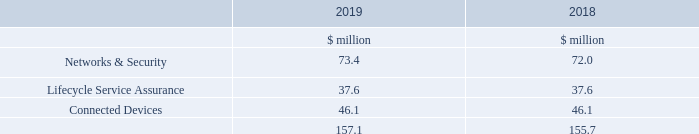13. Intangible assets continued
Goodwill has been allocated to three CGUs, which align with the reportable operating segments, as follows:
What has Goodwill been allocated to? Three cgus, which align with the reportable operating segments. What is the amount of intangible assets under Networks & Security in 2019?
Answer scale should be: million. 73.4. What are the three CGUs, which align with the reportable operating segments? Networks & security, lifecycle service assurance, connected devices. In which year was the amount of intangible assets larger? 157.1>155.7
Answer: 2019. What was the change in the total intangible assets?
Answer scale should be: million. 157.1-155.7
Answer: 1.4. What was the percentage change in the total intangible assets?
Answer scale should be: percent. (157.1-155.7)/155.7
Answer: 0.9. 